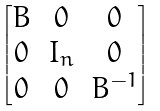Convert formula to latex. <formula><loc_0><loc_0><loc_500><loc_500>\begin{bmatrix} B & 0 & 0 \\ 0 & I _ { n } & 0 \\ 0 & 0 & B ^ { - 1 } \end{bmatrix}</formula> 